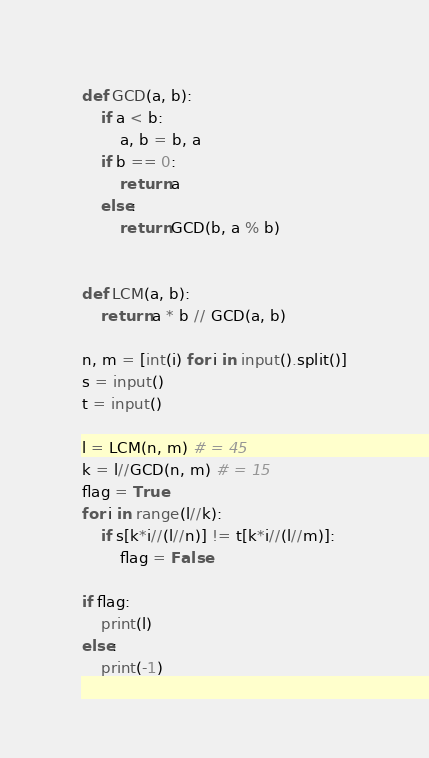Convert code to text. <code><loc_0><loc_0><loc_500><loc_500><_Python_>def GCD(a, b):
    if a < b:
        a, b = b, a
    if b == 0:
        return a
    else:
        return GCD(b, a % b)


def LCM(a, b):
    return a * b // GCD(a, b)

n, m = [int(i) for i in input().split()]
s = input()
t = input()

l = LCM(n, m) # = 45
k = l//GCD(n, m) # = 15
flag = True
for i in range(l//k):
    if s[k*i//(l//n)] != t[k*i//(l//m)]:
        flag = False

if flag:
    print(l)
else:
    print(-1)</code> 